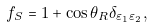Convert formula to latex. <formula><loc_0><loc_0><loc_500><loc_500>f _ { S } = 1 + \cos \theta _ { R } \delta _ { \varepsilon _ { 1 } \varepsilon _ { 2 } } ,</formula> 